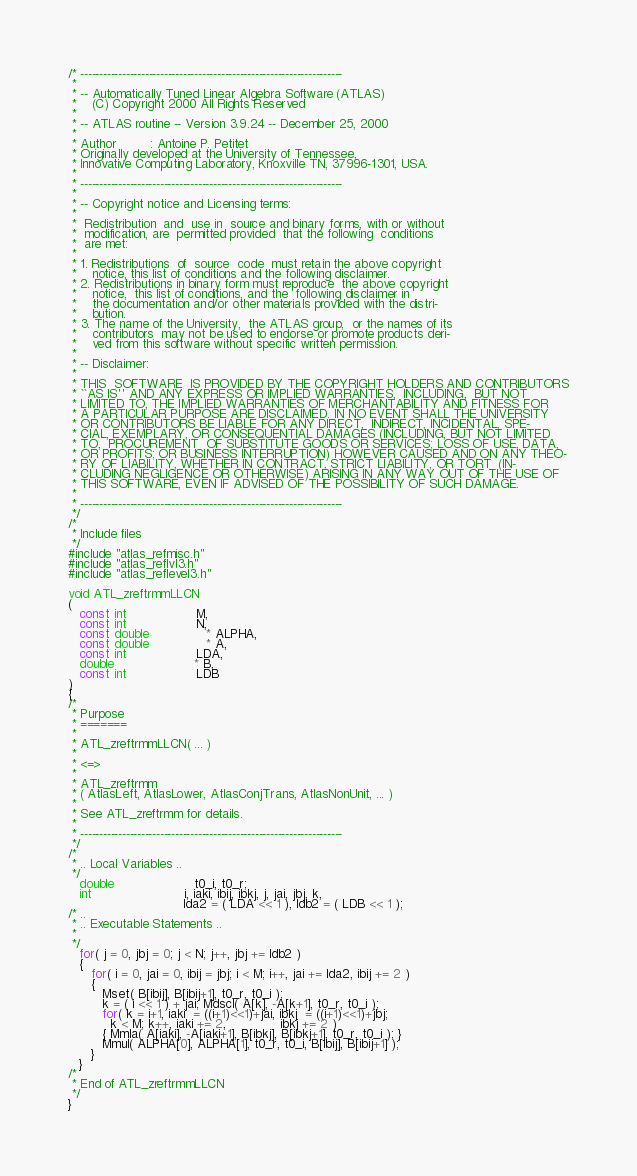<code> <loc_0><loc_0><loc_500><loc_500><_C_>/* ---------------------------------------------------------------------
 *
 * -- Automatically Tuned Linear Algebra Software (ATLAS)
 *    (C) Copyright 2000 All Rights Reserved
 *
 * -- ATLAS routine -- Version 3.9.24 -- December 25, 2000
 *
 * Author         : Antoine P. Petitet
 * Originally developed at the University of Tennessee,
 * Innovative Computing Laboratory, Knoxville TN, 37996-1301, USA.
 *
 * ---------------------------------------------------------------------
 *
 * -- Copyright notice and Licensing terms:
 *
 *  Redistribution  and  use in  source and binary forms, with or without
 *  modification, are  permitted provided  that the following  conditions
 *  are met:
 *
 * 1. Redistributions  of  source  code  must retain the above copyright
 *    notice, this list of conditions and the following disclaimer.
 * 2. Redistributions in binary form must reproduce  the above copyright
 *    notice,  this list of conditions, and the  following disclaimer in
 *    the documentation and/or other materials provided with the distri-
 *    bution.
 * 3. The name of the University,  the ATLAS group,  or the names of its
 *    contributors  may not be used to endorse or promote products deri-
 *    ved from this software without specific written permission.
 *
 * -- Disclaimer:
 *
 * THIS  SOFTWARE  IS PROVIDED BY THE COPYRIGHT HOLDERS AND CONTRIBUTORS
 * ``AS IS'' AND ANY EXPRESS OR IMPLIED WARRANTIES,  INCLUDING,  BUT NOT
 * LIMITED TO, THE IMPLIED WARRANTIES OF MERCHANTABILITY AND FITNESS FOR
 * A PARTICULAR PURPOSE ARE DISCLAIMED. IN NO EVENT SHALL THE UNIVERSITY
 * OR CONTRIBUTORS BE LIABLE FOR ANY DIRECT,  INDIRECT, INCIDENTAL, SPE-
 * CIAL, EXEMPLARY, OR CONSEQUENTIAL DAMAGES (INCLUDING, BUT NOT LIMITED
 * TO,  PROCUREMENT  OF SUBSTITUTE GOODS OR SERVICES; LOSS OF USE, DATA,
 * OR PROFITS; OR BUSINESS INTERRUPTION) HOWEVER CAUSED AND ON ANY THEO-
 * RY OF LIABILITY, WHETHER IN CONTRACT, STRICT LIABILITY, OR TORT  (IN-
 * CLUDING NEGLIGENCE OR OTHERWISE) ARISING IN ANY WAY OUT OF THE USE OF
 * THIS SOFTWARE, EVEN IF ADVISED OF THE POSSIBILITY OF SUCH DAMAGE.
 *
 * ---------------------------------------------------------------------
 */
/*
 * Include files
 */
#include "atlas_refmisc.h"
#include "atlas_reflvl3.h"
#include "atlas_reflevel3.h"

void ATL_zreftrmmLLCN
(
   const int                  M,
   const int                  N,
   const double               * ALPHA,
   const double               * A,
   const int                  LDA,
   double                     * B,
   const int                  LDB
)
{
/*
 * Purpose
 * =======
 *
 * ATL_zreftrmmLLCN( ... )
 *
 * <=>
 *
 * ATL_zreftrmm
 * ( AtlasLeft, AtlasLower, AtlasConjTrans, AtlasNonUnit, ... )
 *
 * See ATL_zreftrmm for details.
 *
 * ---------------------------------------------------------------------
 */
/*
 * .. Local Variables ..
 */
   double                     t0_i, t0_r;
   int                        i, iaki, ibij, ibkj, j, jai, jbj, k,
                              lda2 = ( LDA << 1 ), ldb2 = ( LDB << 1 );
/* ..
 * .. Executable Statements ..
 *
 */
   for( j = 0, jbj = 0; j < N; j++, jbj += ldb2 )
   {
      for( i = 0, jai = 0, ibij = jbj; i < M; i++, jai += lda2, ibij += 2 )
      {
         Mset( B[ibij], B[ibij+1], t0_r, t0_i );
         k = ( i << 1 ) + jai; Mdscl( A[k], -A[k+1], t0_r, t0_i );
         for( k = i+1, iaki  = ((i+1)<<1)+jai, ibkj  = ((i+1)<<1)+jbj;
           k < M; k++, iaki += 2,              ibkj += 2 )
         { Mmla( A[iaki], -A[iaki+1], B[ibkj], B[ibkj+1], t0_r, t0_i ); }
         Mmul( ALPHA[0], ALPHA[1], t0_r, t0_i, B[ibij], B[ibij+1] );
      }
   }
/*
 * End of ATL_zreftrmmLLCN
 */
}
</code> 